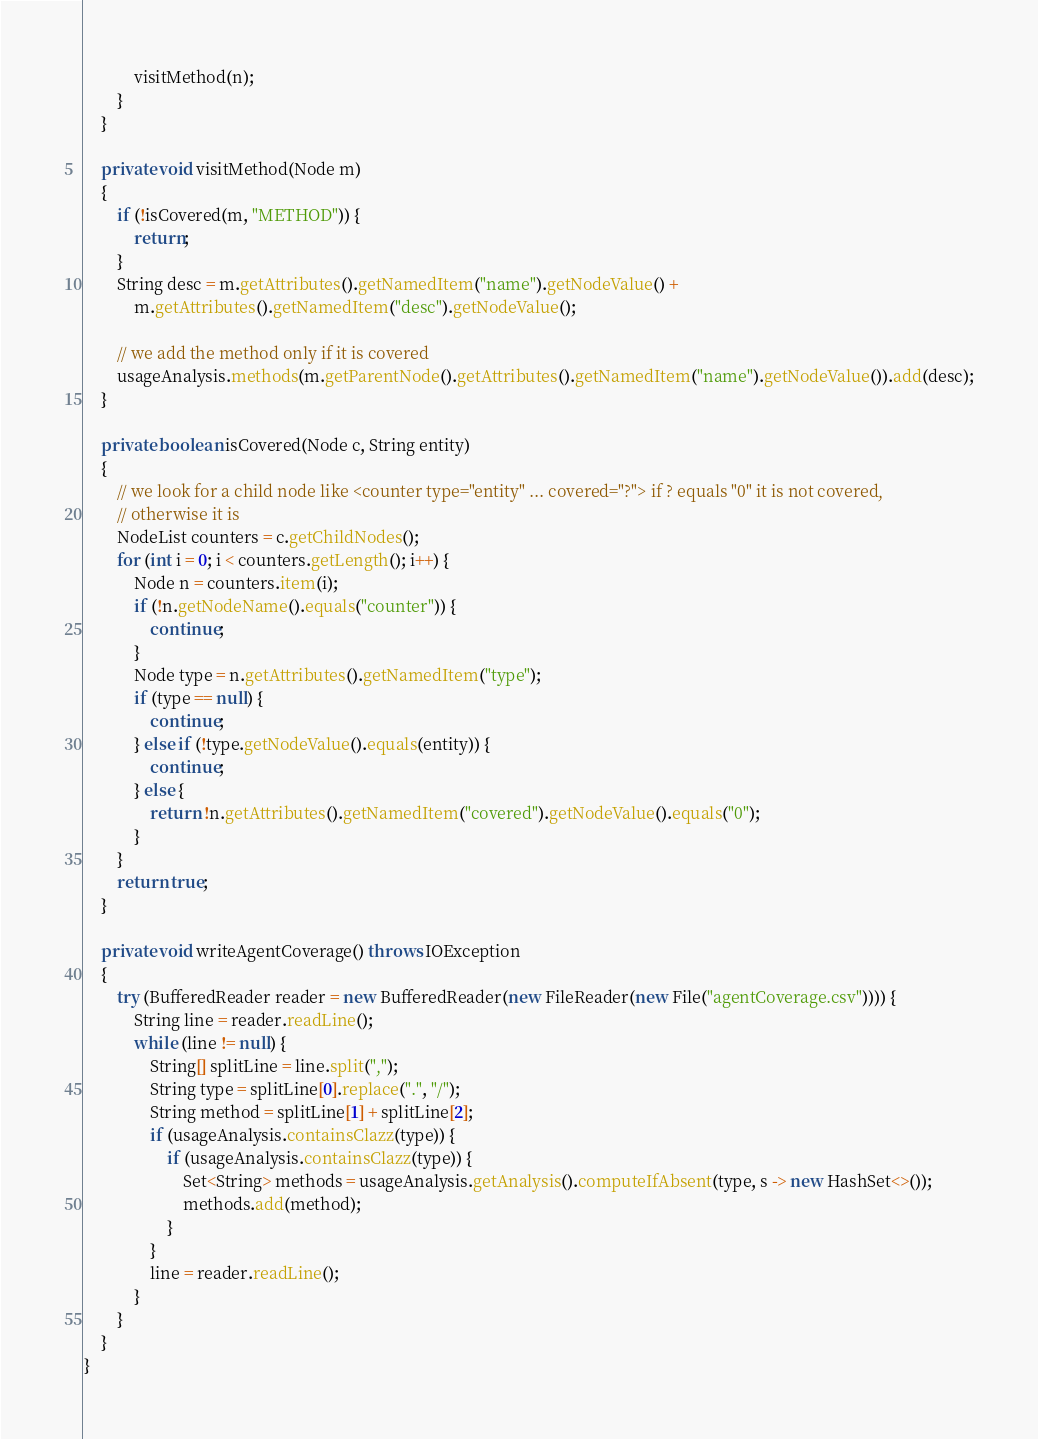<code> <loc_0><loc_0><loc_500><loc_500><_Java_>            visitMethod(n);
        }
    }

    private void visitMethod(Node m)
    {
        if (!isCovered(m, "METHOD")) {
            return;
        }
        String desc = m.getAttributes().getNamedItem("name").getNodeValue() +
            m.getAttributes().getNamedItem("desc").getNodeValue();

        // we add the method only if it is covered
        usageAnalysis.methods(m.getParentNode().getAttributes().getNamedItem("name").getNodeValue()).add(desc);
    }

    private boolean isCovered(Node c, String entity)
    {
        // we look for a child node like <counter type="entity" ... covered="?"> if ? equals "0" it is not covered,
        // otherwise it is
        NodeList counters = c.getChildNodes();
        for (int i = 0; i < counters.getLength(); i++) {
            Node n = counters.item(i);
            if (!n.getNodeName().equals("counter")) {
                continue;
            }
            Node type = n.getAttributes().getNamedItem("type");
            if (type == null) {
                continue;
            } else if (!type.getNodeValue().equals(entity)) {
                continue;
            } else {
                return !n.getAttributes().getNamedItem("covered").getNodeValue().equals("0");
            }
        }
        return true;
    }

    private void writeAgentCoverage() throws IOException
    {
        try (BufferedReader reader = new BufferedReader(new FileReader(new File("agentCoverage.csv")))) {
            String line = reader.readLine();
            while (line != null) {
                String[] splitLine = line.split(",");
                String type = splitLine[0].replace(".", "/");
                String method = splitLine[1] + splitLine[2];
                if (usageAnalysis.containsClazz(type)) {
                    if (usageAnalysis.containsClazz(type)) {
                        Set<String> methods = usageAnalysis.getAnalysis().computeIfAbsent(type, s -> new HashSet<>());
                        methods.add(method);
                    }
                }
                line = reader.readLine();
            }
        }
    }
}
</code> 